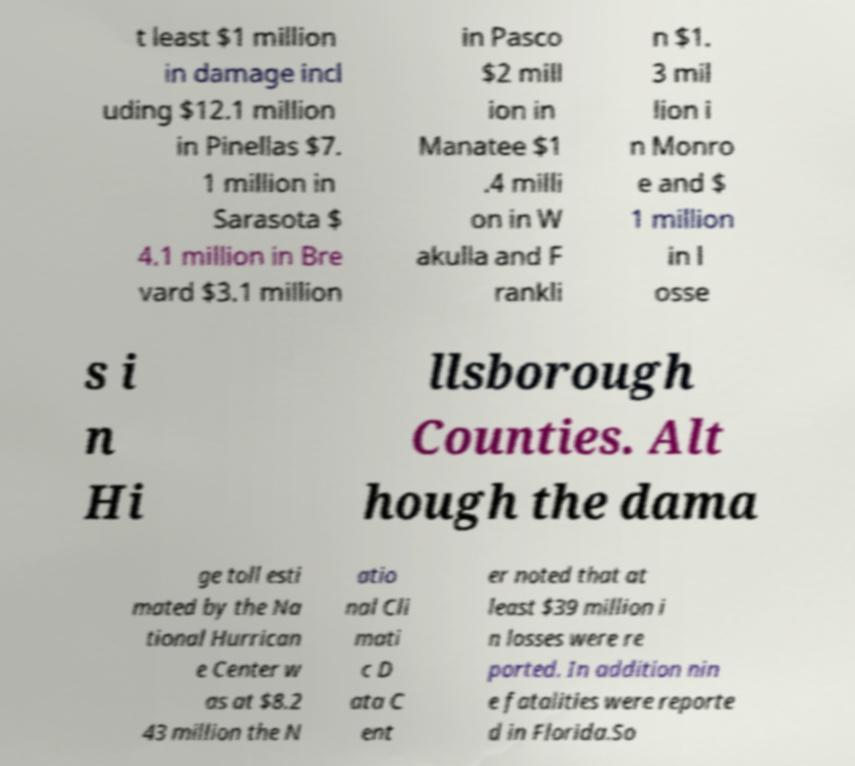For documentation purposes, I need the text within this image transcribed. Could you provide that? t least $1 million in damage incl uding $12.1 million in Pinellas $7. 1 million in Sarasota $ 4.1 million in Bre vard $3.1 million in Pasco $2 mill ion in Manatee $1 .4 milli on in W akulla and F rankli n $1. 3 mil lion i n Monro e and $ 1 million in l osse s i n Hi llsborough Counties. Alt hough the dama ge toll esti mated by the Na tional Hurrican e Center w as at $8.2 43 million the N atio nal Cli mati c D ata C ent er noted that at least $39 million i n losses were re ported. In addition nin e fatalities were reporte d in Florida.So 